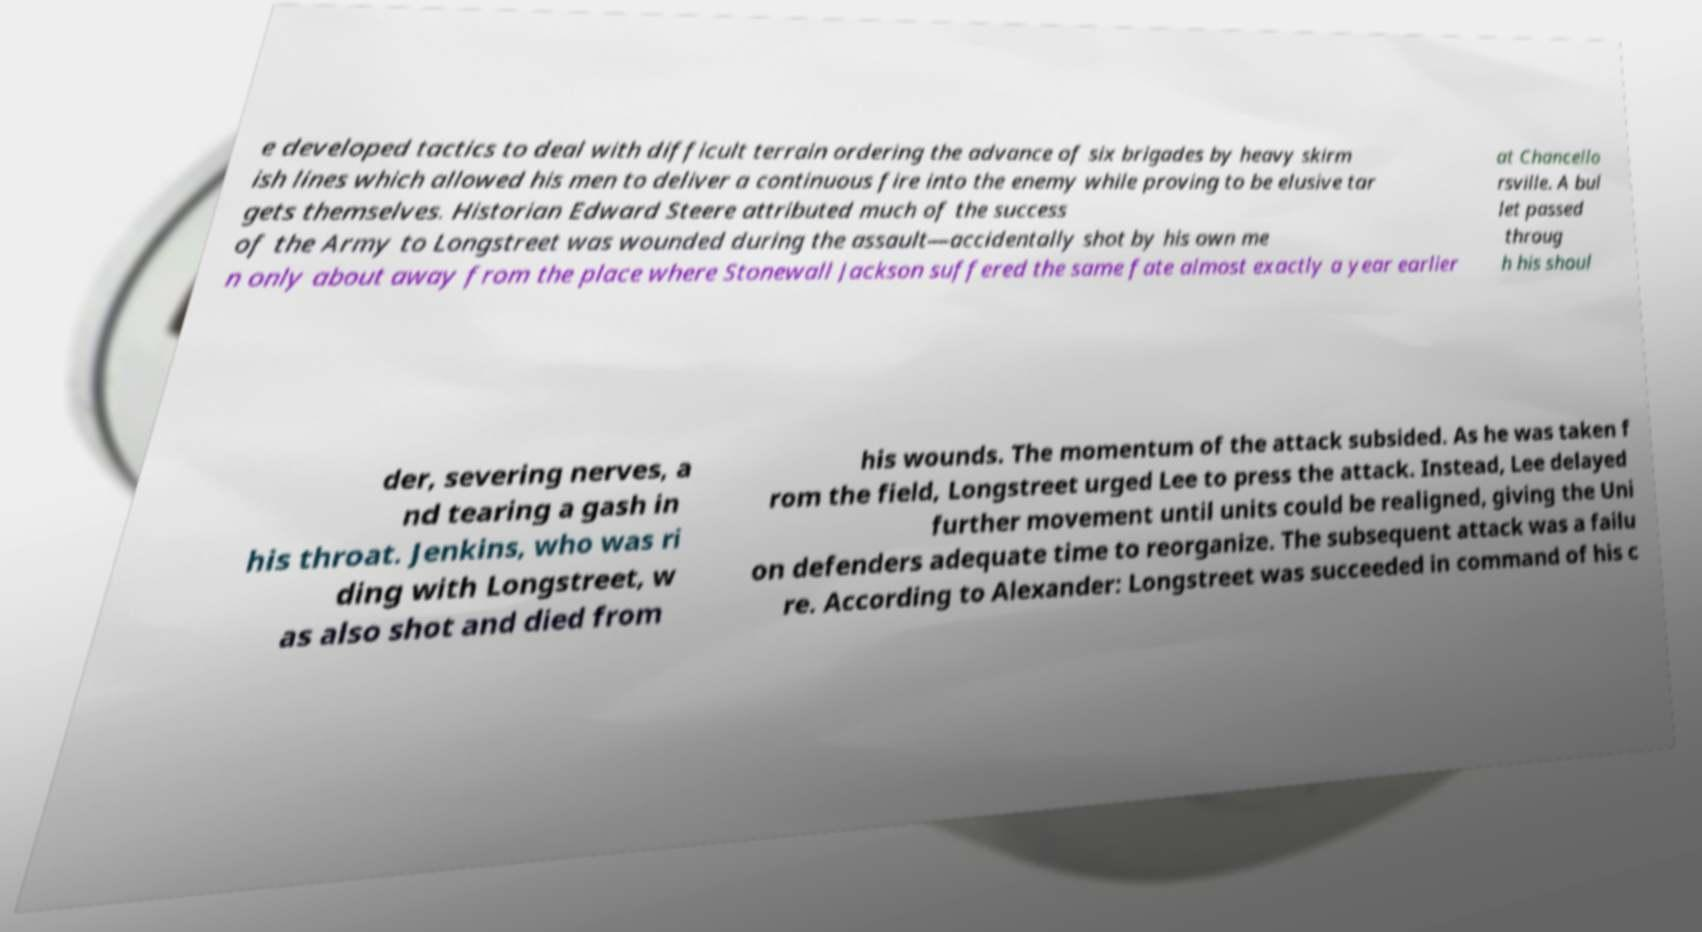I need the written content from this picture converted into text. Can you do that? e developed tactics to deal with difficult terrain ordering the advance of six brigades by heavy skirm ish lines which allowed his men to deliver a continuous fire into the enemy while proving to be elusive tar gets themselves. Historian Edward Steere attributed much of the success of the Army to Longstreet was wounded during the assault—accidentally shot by his own me n only about away from the place where Stonewall Jackson suffered the same fate almost exactly a year earlier at Chancello rsville. A bul let passed throug h his shoul der, severing nerves, a nd tearing a gash in his throat. Jenkins, who was ri ding with Longstreet, w as also shot and died from his wounds. The momentum of the attack subsided. As he was taken f rom the field, Longstreet urged Lee to press the attack. Instead, Lee delayed further movement until units could be realigned, giving the Uni on defenders adequate time to reorganize. The subsequent attack was a failu re. According to Alexander: Longstreet was succeeded in command of his c 